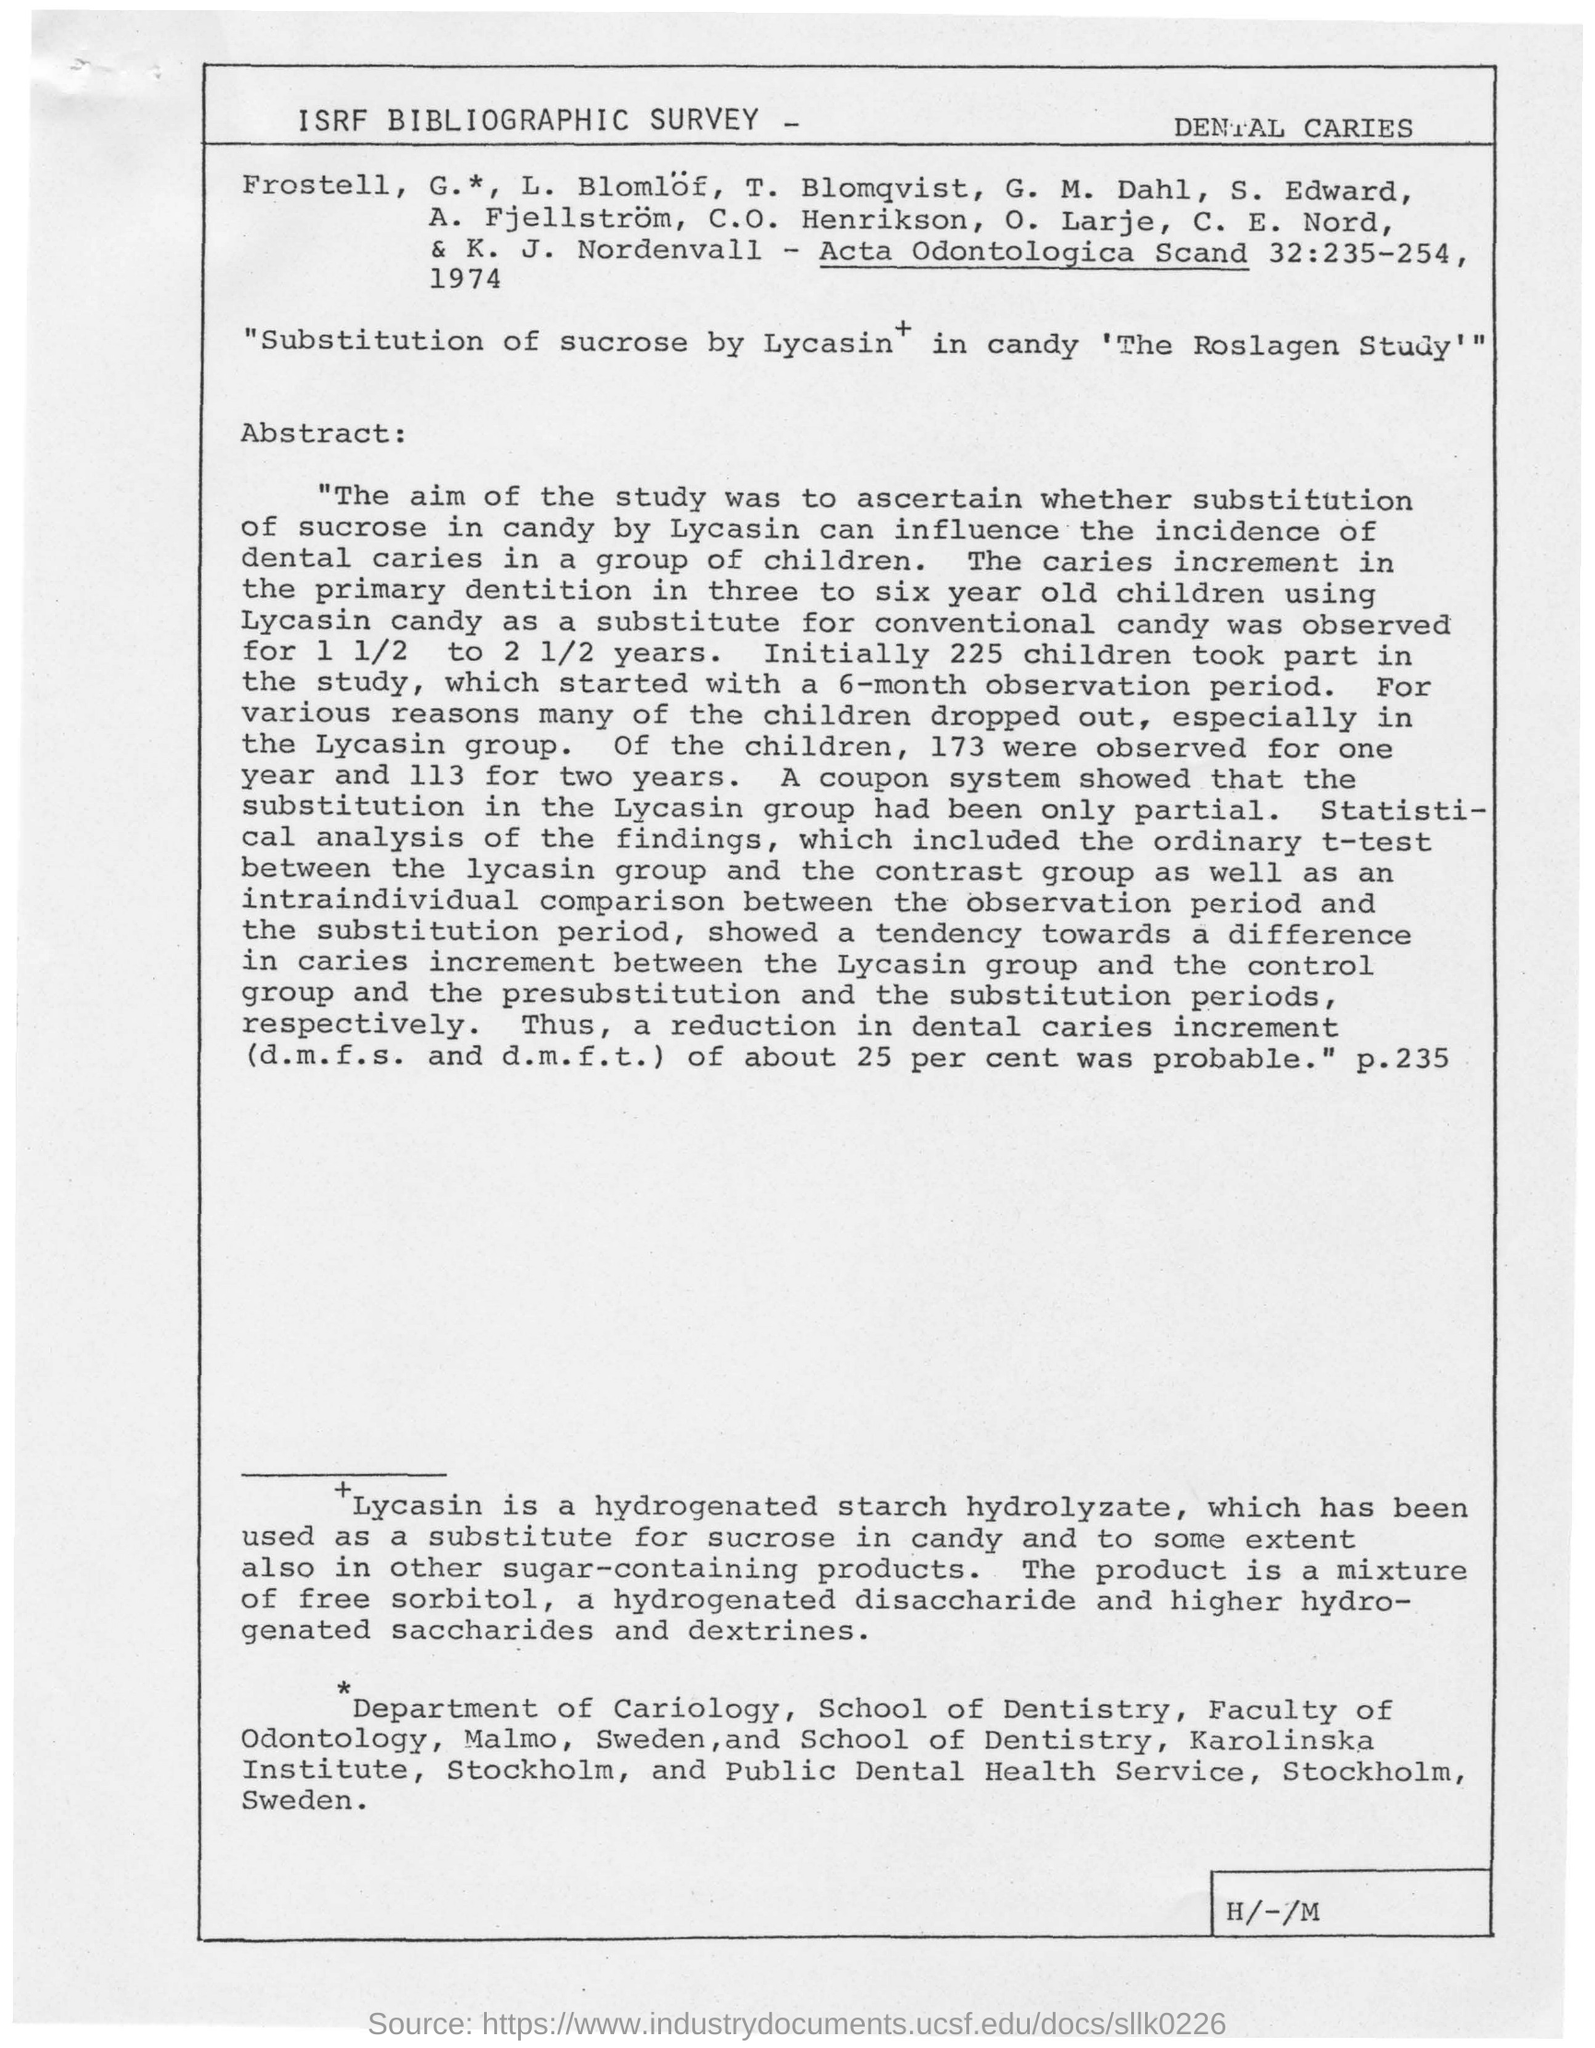What is the substitution of sucrose in candy
Make the answer very short. Lycasin. Which hydrogenated strach hrdrolyzate has been used as substitute for sucrose in candy?
Provide a succinct answer. Lycasin. What is the age group of children affected by dental caries?
Ensure brevity in your answer.  Three to six year old. How many children took part in the study?
Make the answer very short. 225 children took part in the study. How many children were observed for one year?
Provide a succinct answer. 173 children were observed for one year. How many children were observed for two years?
Your answer should be compact. 113. Which system showed that the substitution in the Lycasin group had been partial?
Provide a succinct answer. A coupon system. How long was the study on substitute for conventional candy done?
Offer a very short reply. For 1 1/2 to 2 1/2 years. 